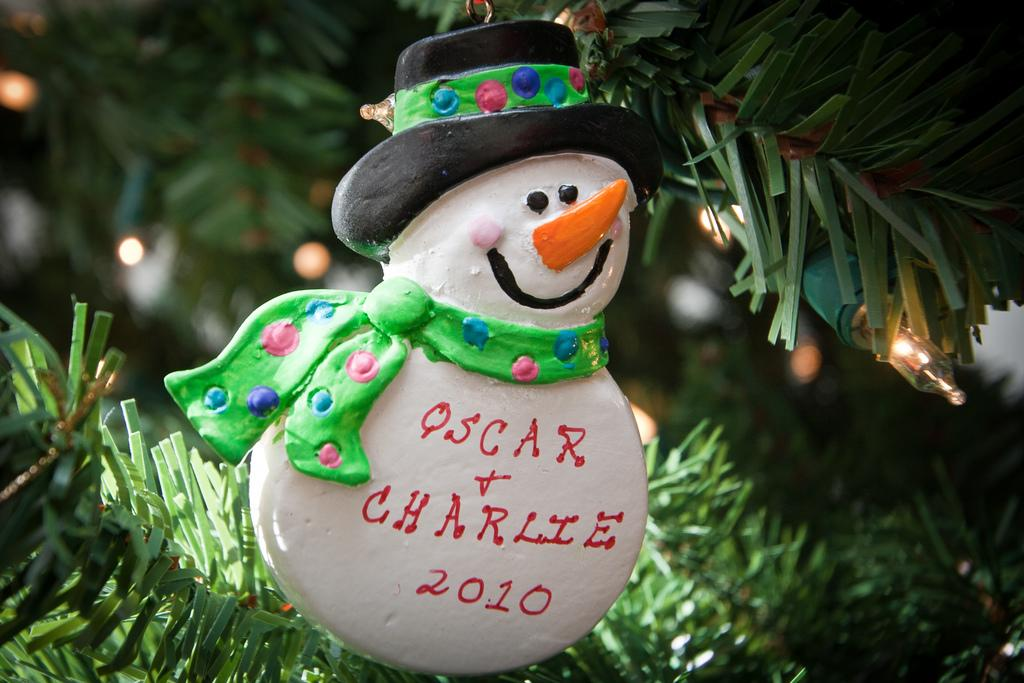What is the main subject of the image? There is a doll in the image. What else can be seen in the image besides the doll? Leaves and a bulb are visible in the image. How many fowls are present in the image? There are no fowls present in the image; it only features a doll, leaves, and a bulb. What type of apple is being held by the doll in the image? There is no apple present in the image; the doll is not holding anything. 